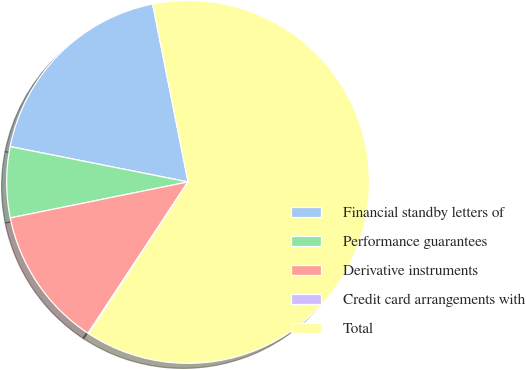Convert chart to OTSL. <chart><loc_0><loc_0><loc_500><loc_500><pie_chart><fcel>Financial standby letters of<fcel>Performance guarantees<fcel>Derivative instruments<fcel>Credit card arrangements with<fcel>Total<nl><fcel>18.75%<fcel>6.3%<fcel>12.53%<fcel>0.07%<fcel>62.35%<nl></chart> 